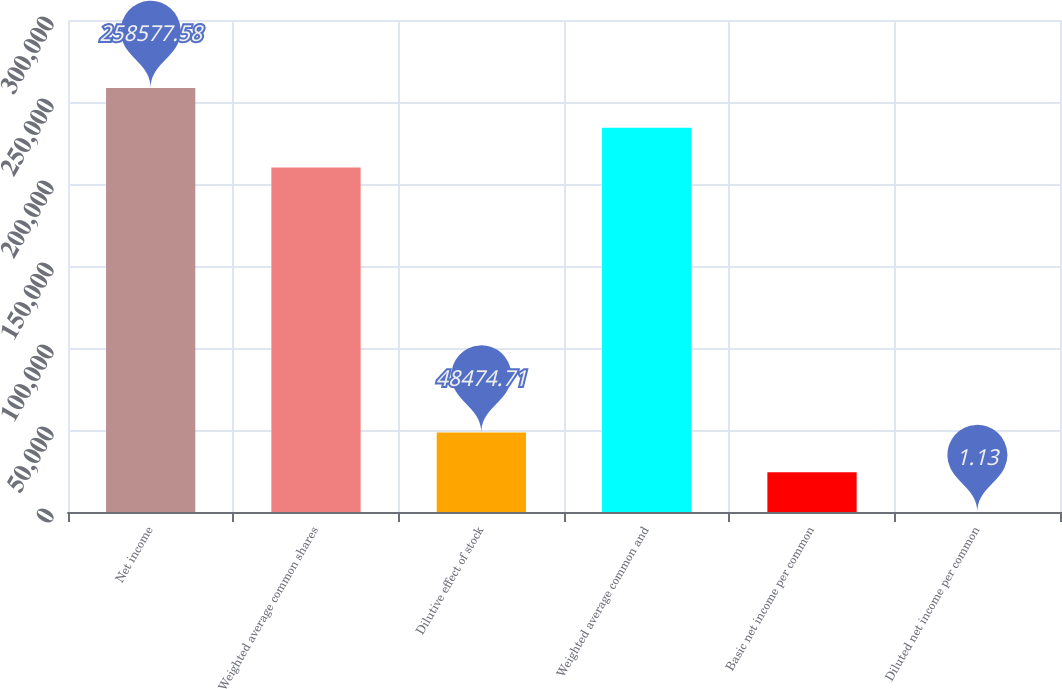Convert chart. <chart><loc_0><loc_0><loc_500><loc_500><bar_chart><fcel>Net income<fcel>Weighted average common shares<fcel>Dilutive effect of stock<fcel>Weighted average common and<fcel>Basic net income per common<fcel>Diluted net income per common<nl><fcel>258578<fcel>210104<fcel>48474.7<fcel>234341<fcel>24237.9<fcel>1.13<nl></chart> 